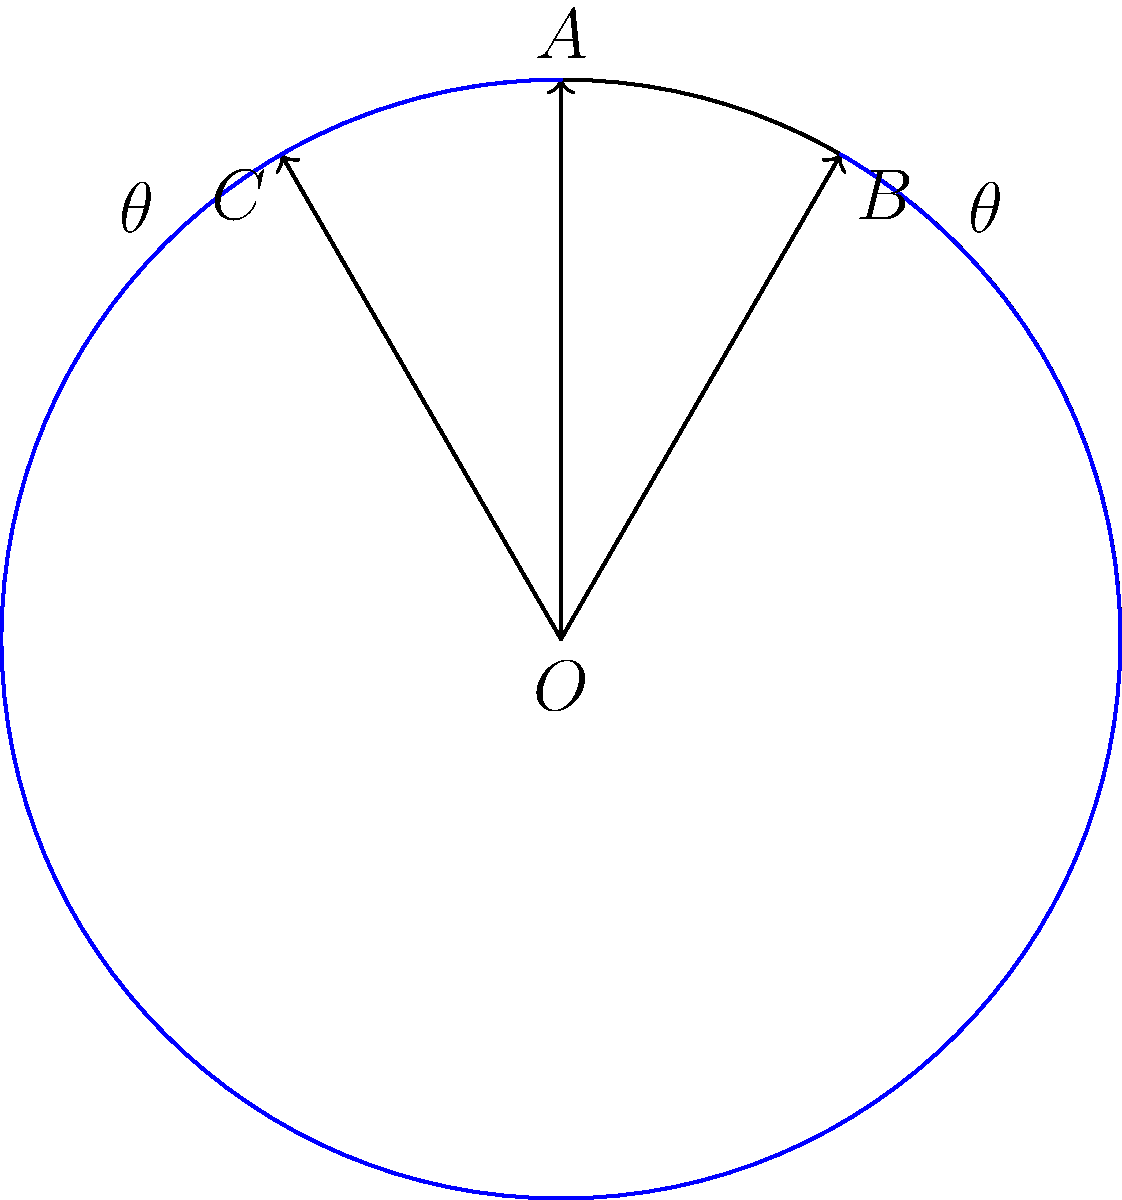In your circular bookshelf display, you've arranged a series of espionage novels so that their spines form a fan-like pattern. If the angle between each book spine is $\theta$, and the arc length between the first and last book is 60 cm on a shelf with a radius of 50 cm, how many books can you fit in this display? Let's approach this step-by-step:

1) First, we need to find the central angle that corresponds to the given arc length. We can use the formula for arc length:

   $s = r\theta$

   Where $s$ is the arc length, $r$ is the radius, and $\theta$ is the central angle in radians.

2) Substituting the given values:

   $60 = 50\theta$

3) Solving for $\theta$:

   $\theta = \frac{60}{50} = 1.2$ radians

4) This is the total central angle. To find how many books we can fit, we need to divide this by the angle between each book spine:

   Number of spaces = $\frac{1.2}{\theta}$

5) The question states that the angle between each book spine is $\theta$. From the diagram, we can see that this angle is 30°.

6) Convert 30° to radians:

   $30° = \frac{30 \pi}{180} = \frac{\pi}{6}$ radians

7) Now we can calculate the number of spaces:

   Number of spaces = $\frac{1.2}{\frac{\pi}{6}} = \frac{1.2 \cdot 6}{\pi} = \frac{7.2}{\pi} \approx 2.29$

8) Since we can only have a whole number of books, we round down to 2.

9) The number of books is one more than the number of spaces between books.

Therefore, you can fit 3 books in this display.
Answer: 3 books 